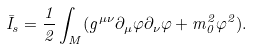Convert formula to latex. <formula><loc_0><loc_0><loc_500><loc_500>\bar { I } _ { s } = \frac { 1 } { 2 } \int _ { M } ( g ^ { \mu \nu } \partial _ { \mu } \varphi \partial _ { \nu } \varphi + m ^ { 2 } _ { 0 } \varphi ^ { 2 } ) .</formula> 